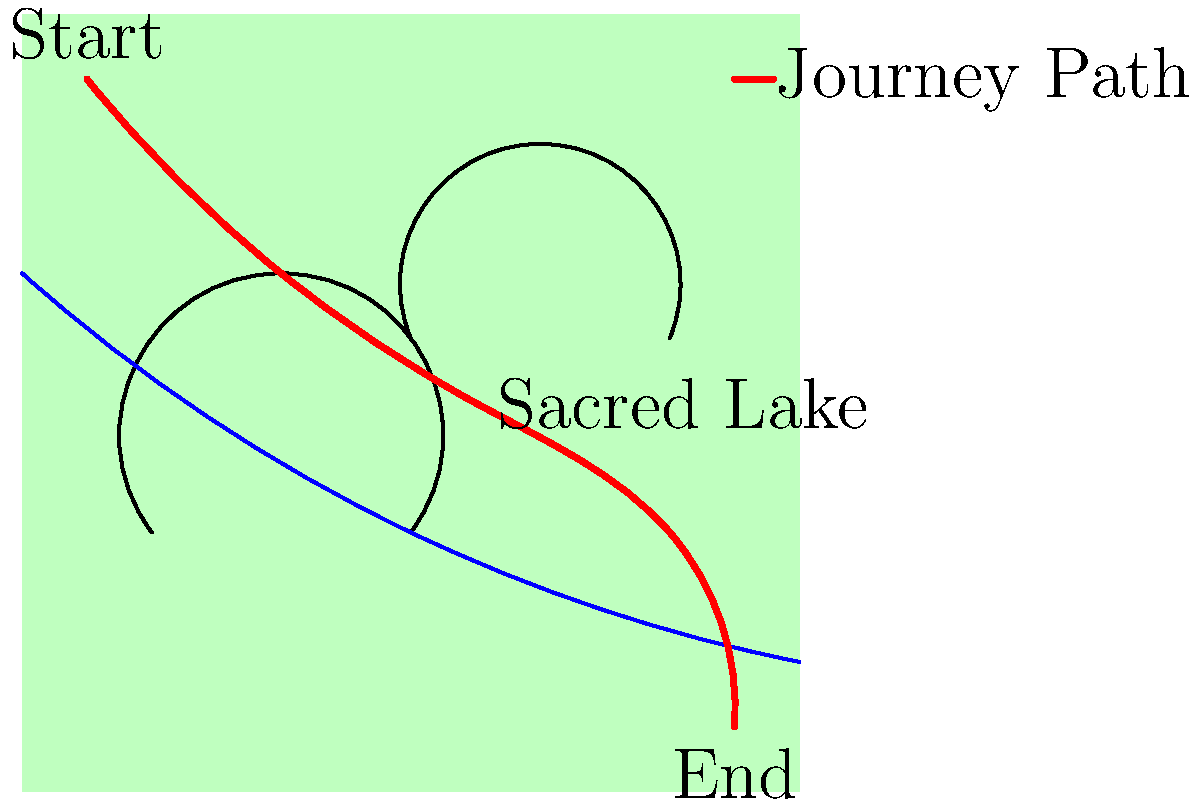A Tibetan treasure revealer embarks on a journey to discover hidden spiritual texts. Using the topographical map provided, trace their path from start to end. What significant landmark do they encounter along the way, and how might this relate to the practice of treasure revelation in Tibetan Buddhism? 1. The map shows a topographical representation of a Tibetan landscape, with mountains, a river, and a marked journey path.

2. The journey begins at the point labeled "Start" in the upper left corner of the map.

3. Following the red line, we can trace the treasure revealer's path as it winds through the landscape.

4. Midway through the journey, the path passes by a point labeled "Sacred Lake."

5. The journey continues past the lake and ends at the point labeled "End" in the lower right corner of the map.

6. In Tibetan Buddhism, lakes are often considered sacred places and are associated with hidden treasures or terma.

7. Treasure revealers, known as tertons, are believed to discover hidden spiritual texts and objects, often in natural settings like lakes, caves, or mountains.

8. The sacred lake encountered on this journey could be a potential site for treasure revelation, where the terton might meditate, receive visions, or uncover hidden teachings.

9. This landmark is significant because it represents the intersection of the physical landscape with the spiritual practice of treasure revelation, a key aspect of Tibetan Buddhist mysticism.

10. The journey depicted could symbolize both a physical pilgrimage and a spiritual quest, reflecting the holistic nature of the treasure revealer's practice in Tibetan Buddhism.
Answer: Sacred Lake; potential site for treasure revelation 